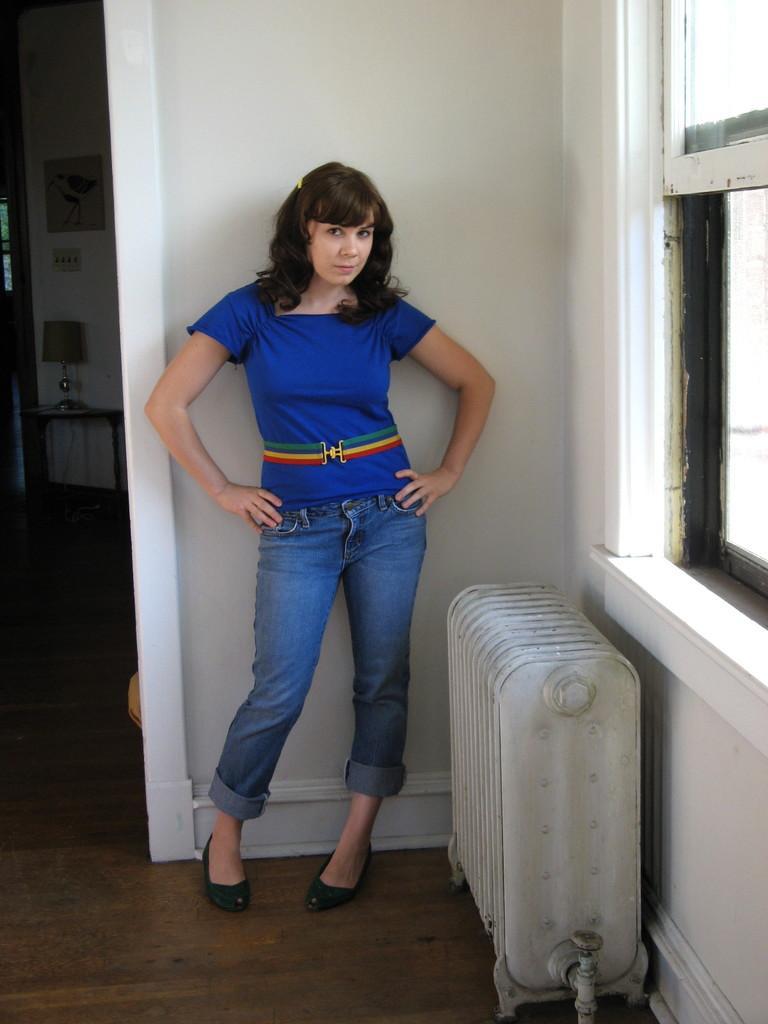Describe this image in one or two sentences. In the center of the image we can see one woman standing and she is wearing blue color t shirt. In the background there is a wall, window, table, lamp, photo frame, switchboard, white color object and a few other objects. 